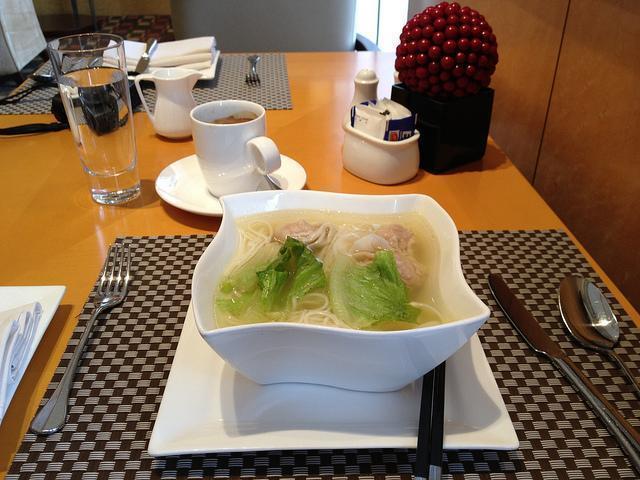How many bowls can you see?
Give a very brief answer. 2. How many cups can be seen?
Give a very brief answer. 2. How many women are under the umbrella?
Give a very brief answer. 0. 